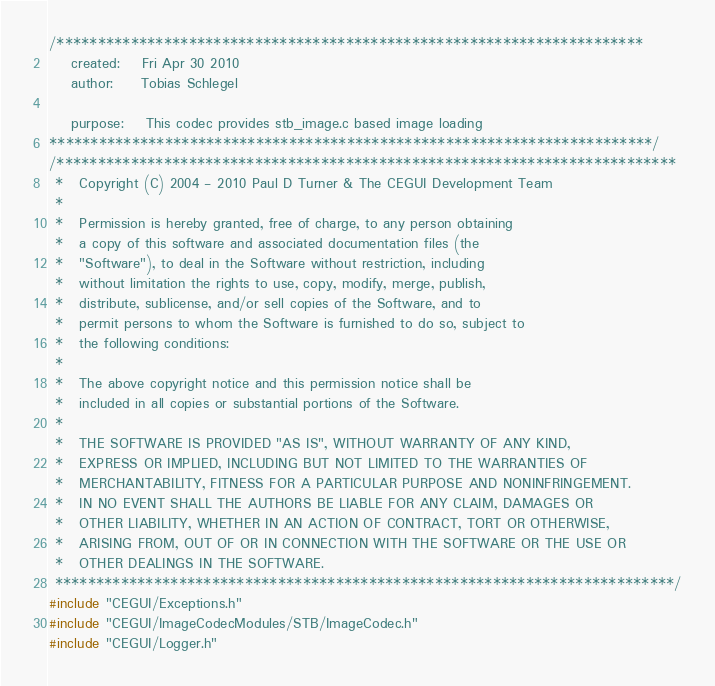Convert code to text. <code><loc_0><loc_0><loc_500><loc_500><_C++_>/***********************************************************************
	created:	Fri Apr 30 2010
	author:		Tobias Schlegel

	purpose:	This codec provides stb_image.c based image loading
*************************************************************************/
/***************************************************************************
 *   Copyright (C) 2004 - 2010 Paul D Turner & The CEGUI Development Team
 *
 *   Permission is hereby granted, free of charge, to any person obtaining
 *   a copy of this software and associated documentation files (the
 *   "Software"), to deal in the Software without restriction, including
 *   without limitation the rights to use, copy, modify, merge, publish,
 *   distribute, sublicense, and/or sell copies of the Software, and to
 *   permit persons to whom the Software is furnished to do so, subject to
 *   the following conditions:
 *
 *   The above copyright notice and this permission notice shall be
 *   included in all copies or substantial portions of the Software.
 *
 *   THE SOFTWARE IS PROVIDED "AS IS", WITHOUT WARRANTY OF ANY KIND,
 *   EXPRESS OR IMPLIED, INCLUDING BUT NOT LIMITED TO THE WARRANTIES OF
 *   MERCHANTABILITY, FITNESS FOR A PARTICULAR PURPOSE AND NONINFRINGEMENT.
 *   IN NO EVENT SHALL THE AUTHORS BE LIABLE FOR ANY CLAIM, DAMAGES OR
 *   OTHER LIABILITY, WHETHER IN AN ACTION OF CONTRACT, TORT OR OTHERWISE,
 *   ARISING FROM, OUT OF OR IN CONNECTION WITH THE SOFTWARE OR THE USE OR
 *   OTHER DEALINGS IN THE SOFTWARE.
 ***************************************************************************/
#include "CEGUI/Exceptions.h"
#include "CEGUI/ImageCodecModules/STB/ImageCodec.h"
#include "CEGUI/Logger.h"</code> 